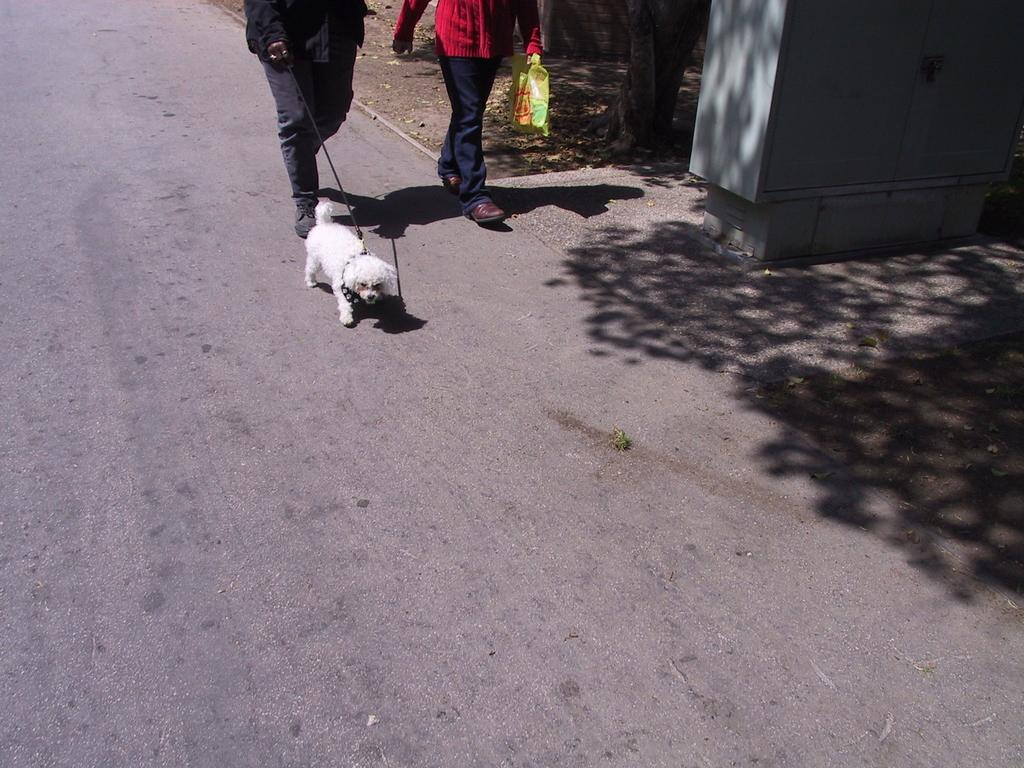What is the main subject of the image? There is a person walking in the image. Is the person walking alone or with someone? The person is accompanied by a dog. Where are they walking? They are on a road. Are there any other people in the image? Yes, there is another person beside them. What type of food is the person carrying in the image? There is no food visible in the image. 